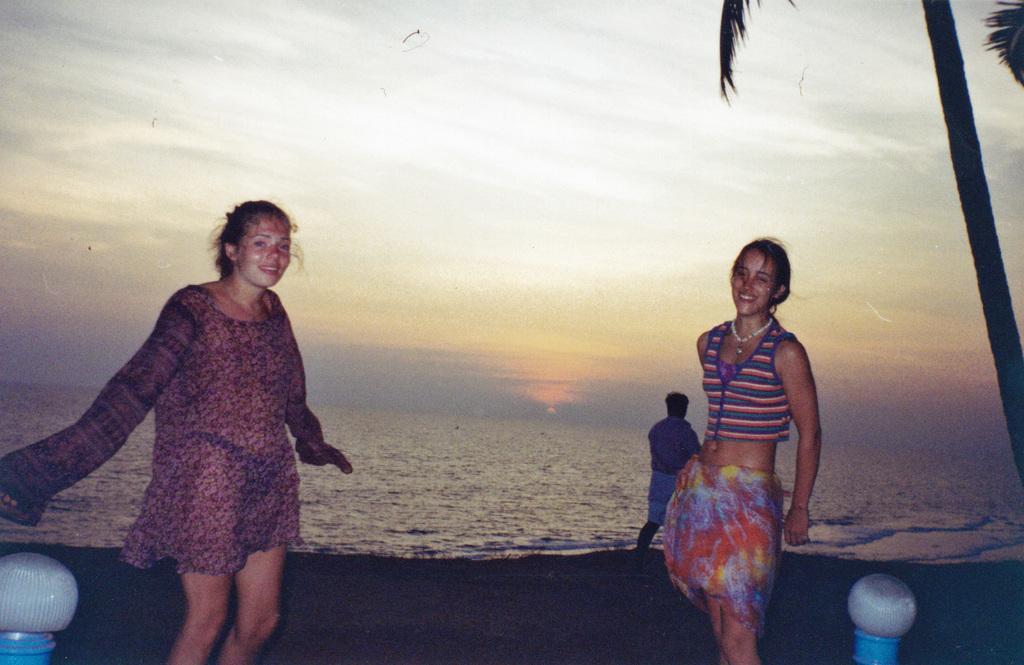Can you describe this image briefly? There are two women standing and we can see tree. On the background we can see person,water and sky. 